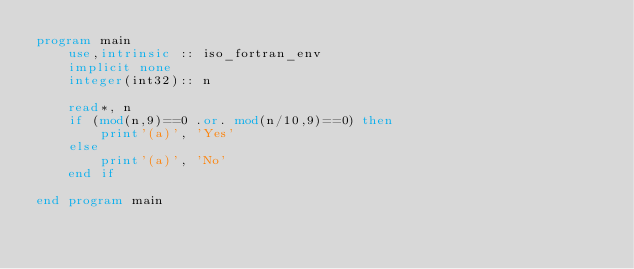Convert code to text. <code><loc_0><loc_0><loc_500><loc_500><_FORTRAN_>program main
    use,intrinsic :: iso_fortran_env
    implicit none
    integer(int32):: n

    read*, n
    if (mod(n,9)==0 .or. mod(n/10,9)==0) then
        print'(a)', 'Yes'
    else
        print'(a)', 'No'
    end if
    
end program main</code> 